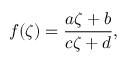Convert formula to latex. <formula><loc_0><loc_0><loc_500><loc_500>f ( \zeta ) = { \frac { a \zeta + b } { c \zeta + d } } ,</formula> 